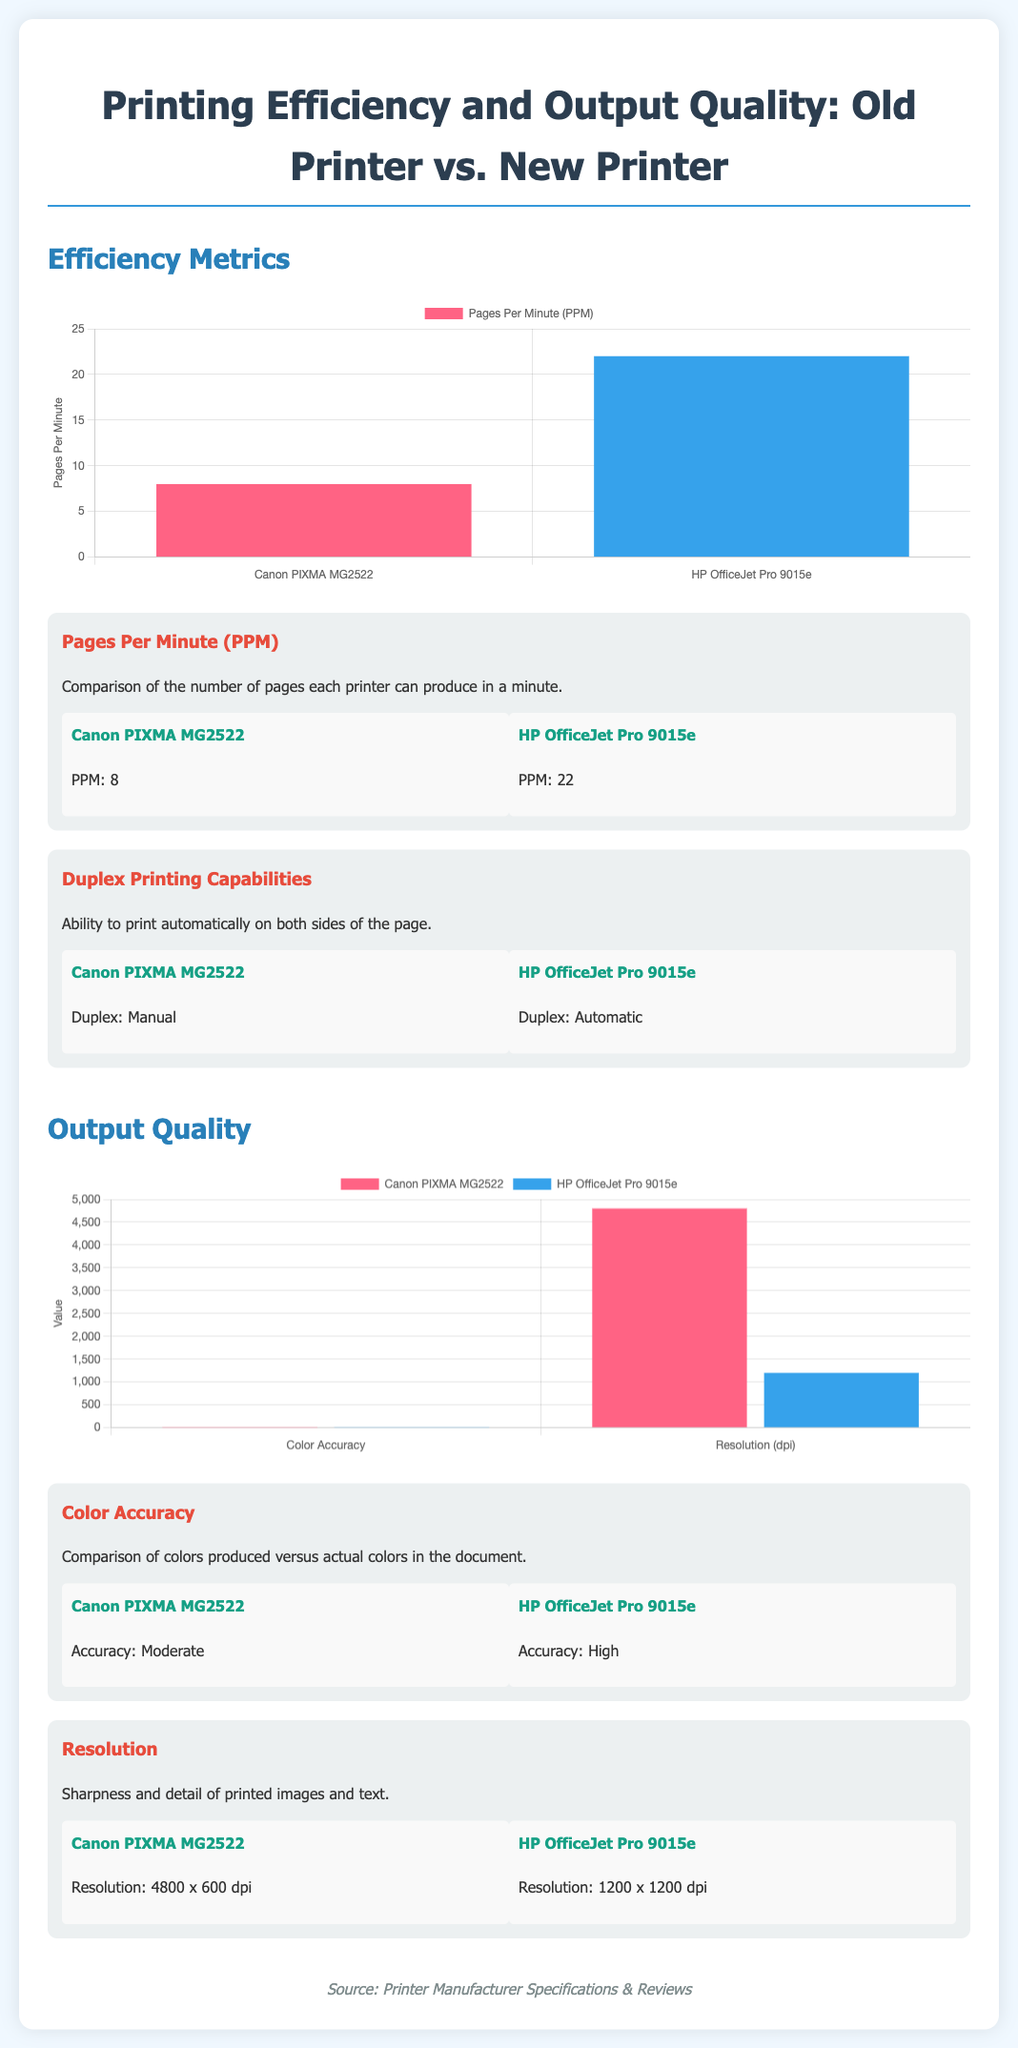What is the pages per minute for Canon PIXMA MG2522? The document states that the Canon PIXMA MG2522 has a pages per minute metric of 8.
Answer: 8 What is the pages per minute for HP OfficeJet Pro 9015e? According to the document, the HP OfficeJet Pro 9015e has a pages per minute metric of 22.
Answer: 22 What is the duplex printing capability of Canon PIXMA MG2522? The document indicates that the duplex printing capability of the Canon PIXMA MG2522 is manual.
Answer: Manual What is the duplex printing capability of HP OfficeJet Pro 9015e? The document states that the duplex printing capability of the HP OfficeJet Pro 9015e is automatic.
Answer: Automatic What is the color accuracy rating for Canon PIXMA MG2522? The document mentions that the color accuracy for the Canon PIXMA MG2522 is moderate.
Answer: Moderate What is the color accuracy rating for HP OfficeJet Pro 9015e? According to the document, the color accuracy for the HP OfficeJet Pro 9015e is high.
Answer: High What is the resolution of Canon PIXMA MG2522? The document states that the resolution of the Canon PIXMA MG2522 is 4800 x 600 dpi.
Answer: 4800 x 600 dpi What is the resolution of HP OfficeJet Pro 9015e? The document indicates that the resolution of the HP OfficeJet Pro 9015e is 1200 x 1200 dpi.
Answer: 1200 x 1200 dpi Which printer has better pages per minute performance? Reasoning from the document, the comparison shows that the HP OfficeJet Pro 9015e has a better pages per minute performance than the Canon PIXMA MG2522.
Answer: HP OfficeJet Pro 9015e Which printer has higher color accuracy? Based on the information in the document, the HP OfficeJet Pro 9015e has higher color accuracy compared to the Canon PIXMA MG2522.
Answer: HP OfficeJet Pro 9015e 